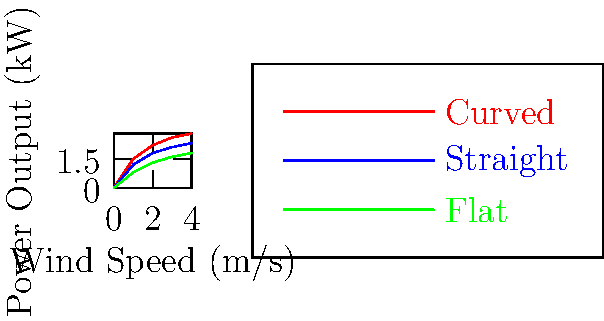Looking at this graph of windmill blade shapes and their power output, which blade shape would you recommend for a small farm in Kansas to generate the most electricity, especially on days with gentle breezes? Let's break this down step-by-step:

1. The graph shows three different blade shapes: Curved (red), Straight (blue), and Flat (green).

2. The x-axis represents wind speed in meters per second (m/s), while the y-axis shows power output in kilowatts (kW).

3. For lower wind speeds (0-2 m/s), which are more common in gentle breezes:
   - Curved blades (red line) produce the most power
   - Straight blades (blue line) are second-best
   - Flat blades (green line) produce the least power

4. As wind speed increases, the difference in power output becomes more pronounced.

5. In Kansas, especially on a small farm, wind speeds can vary but are often in the lower range.

6. The curved blade design is most efficient at converting low-speed winds into power, which is ideal for areas with gentle breezes.

Therefore, based on this graph and considering the need for efficiency in gentle breezes, the curved blade shape would be the best recommendation for a small farm in Kansas.
Answer: Curved blades 